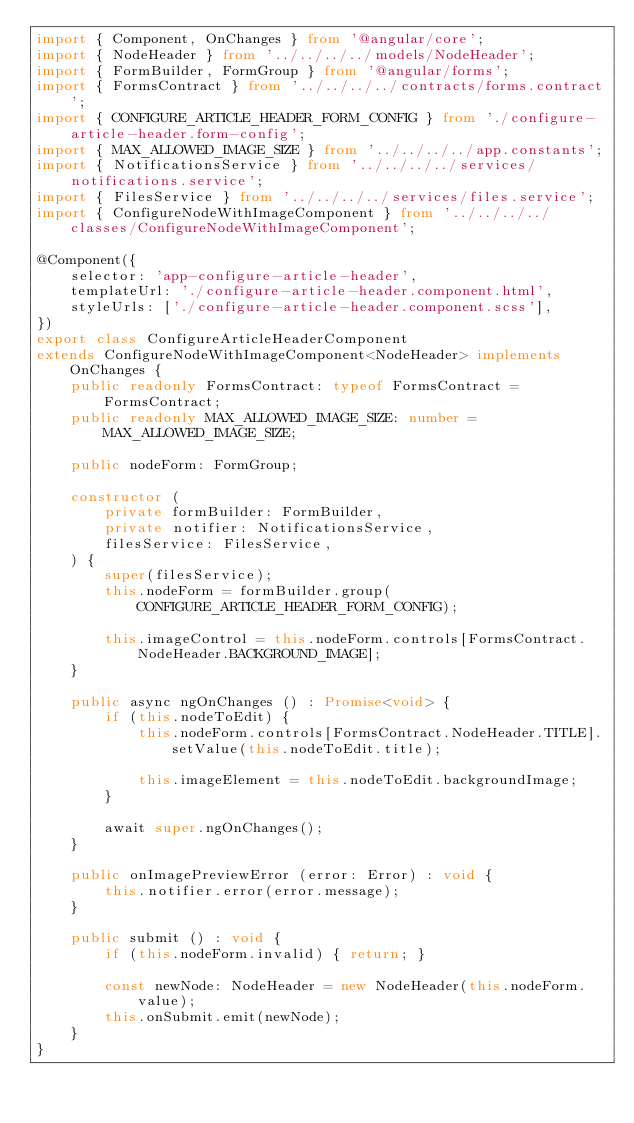<code> <loc_0><loc_0><loc_500><loc_500><_TypeScript_>import { Component, OnChanges } from '@angular/core';
import { NodeHeader } from '../../../../models/NodeHeader';
import { FormBuilder, FormGroup } from '@angular/forms';
import { FormsContract } from '../../../../contracts/forms.contract';
import { CONFIGURE_ARTICLE_HEADER_FORM_CONFIG } from './configure-article-header.form-config';
import { MAX_ALLOWED_IMAGE_SIZE } from '../../../../app.constants';
import { NotificationsService } from '../../../../services/notifications.service';
import { FilesService } from '../../../../services/files.service';
import { ConfigureNodeWithImageComponent } from '../../../../classes/ConfigureNodeWithImageComponent';

@Component({
    selector: 'app-configure-article-header',
    templateUrl: './configure-article-header.component.html',
    styleUrls: ['./configure-article-header.component.scss'],
})
export class ConfigureArticleHeaderComponent
extends ConfigureNodeWithImageComponent<NodeHeader> implements OnChanges {
    public readonly FormsContract: typeof FormsContract = FormsContract;
    public readonly MAX_ALLOWED_IMAGE_SIZE: number = MAX_ALLOWED_IMAGE_SIZE;

    public nodeForm: FormGroup;

    constructor (
        private formBuilder: FormBuilder,
        private notifier: NotificationsService,
        filesService: FilesService,
    ) {
        super(filesService);
        this.nodeForm = formBuilder.group(CONFIGURE_ARTICLE_HEADER_FORM_CONFIG);

        this.imageControl = this.nodeForm.controls[FormsContract.NodeHeader.BACKGROUND_IMAGE];
    }

    public async ngOnChanges () : Promise<void> {
        if (this.nodeToEdit) {
            this.nodeForm.controls[FormsContract.NodeHeader.TITLE].setValue(this.nodeToEdit.title);

            this.imageElement = this.nodeToEdit.backgroundImage;
        }

        await super.ngOnChanges();
    }

    public onImagePreviewError (error: Error) : void {
        this.notifier.error(error.message);
    }

    public submit () : void {
        if (this.nodeForm.invalid) { return; }

        const newNode: NodeHeader = new NodeHeader(this.nodeForm.value);
        this.onSubmit.emit(newNode);
    }
}
</code> 